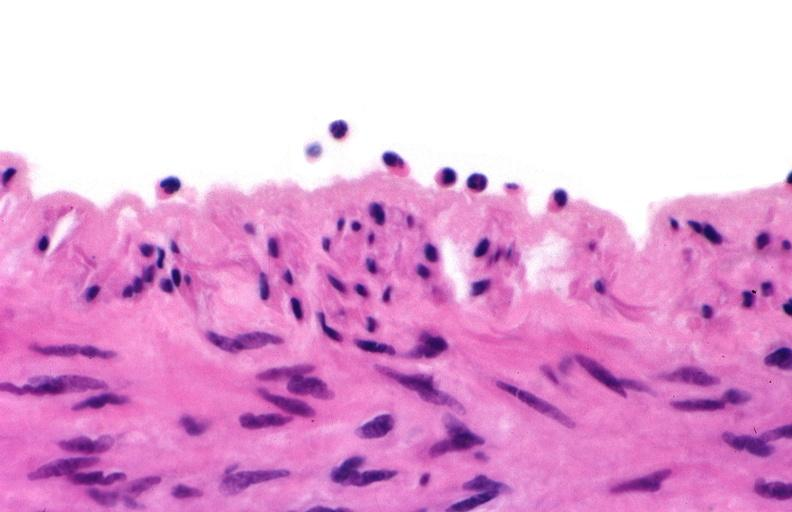s cardiovascular present?
Answer the question using a single word or phrase. Yes 